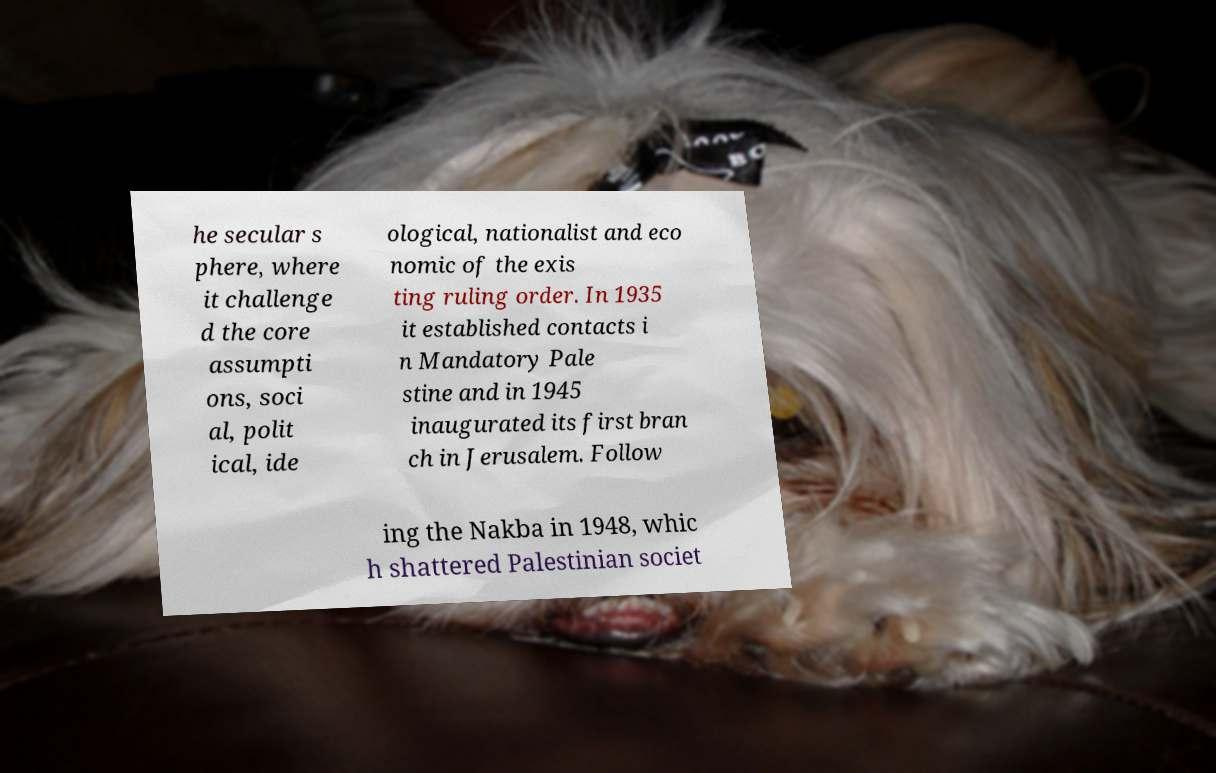Please read and relay the text visible in this image. What does it say? he secular s phere, where it challenge d the core assumpti ons, soci al, polit ical, ide ological, nationalist and eco nomic of the exis ting ruling order. In 1935 it established contacts i n Mandatory Pale stine and in 1945 inaugurated its first bran ch in Jerusalem. Follow ing the Nakba in 1948, whic h shattered Palestinian societ 